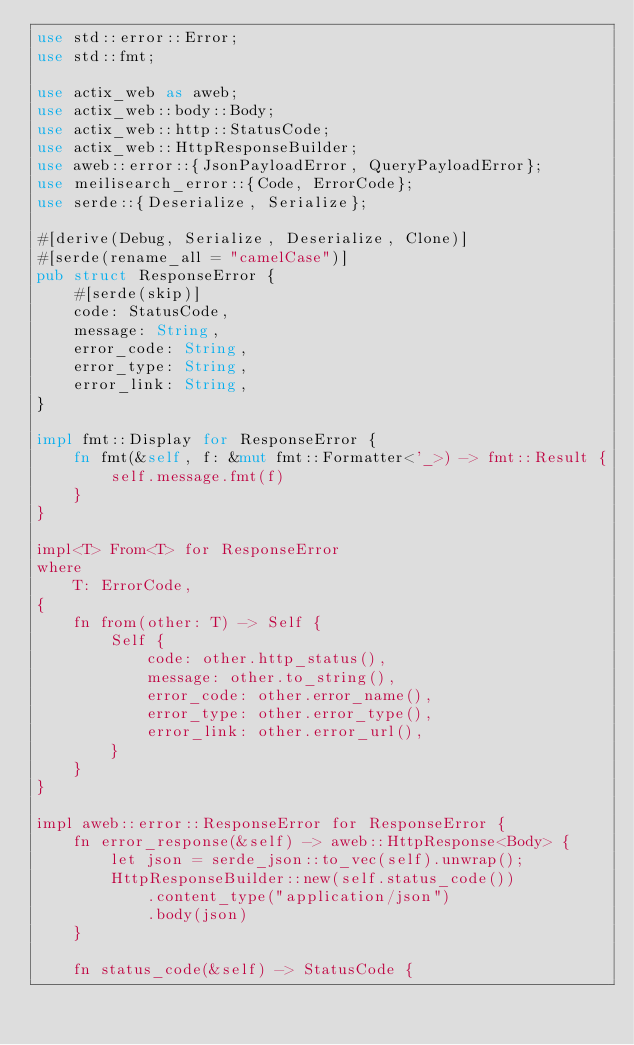<code> <loc_0><loc_0><loc_500><loc_500><_Rust_>use std::error::Error;
use std::fmt;

use actix_web as aweb;
use actix_web::body::Body;
use actix_web::http::StatusCode;
use actix_web::HttpResponseBuilder;
use aweb::error::{JsonPayloadError, QueryPayloadError};
use meilisearch_error::{Code, ErrorCode};
use serde::{Deserialize, Serialize};

#[derive(Debug, Serialize, Deserialize, Clone)]
#[serde(rename_all = "camelCase")]
pub struct ResponseError {
    #[serde(skip)]
    code: StatusCode,
    message: String,
    error_code: String,
    error_type: String,
    error_link: String,
}

impl fmt::Display for ResponseError {
    fn fmt(&self, f: &mut fmt::Formatter<'_>) -> fmt::Result {
        self.message.fmt(f)
    }
}

impl<T> From<T> for ResponseError
where
    T: ErrorCode,
{
    fn from(other: T) -> Self {
        Self {
            code: other.http_status(),
            message: other.to_string(),
            error_code: other.error_name(),
            error_type: other.error_type(),
            error_link: other.error_url(),
        }
    }
}

impl aweb::error::ResponseError for ResponseError {
    fn error_response(&self) -> aweb::HttpResponse<Body> {
        let json = serde_json::to_vec(self).unwrap();
        HttpResponseBuilder::new(self.status_code())
            .content_type("application/json")
            .body(json)
    }

    fn status_code(&self) -> StatusCode {</code> 